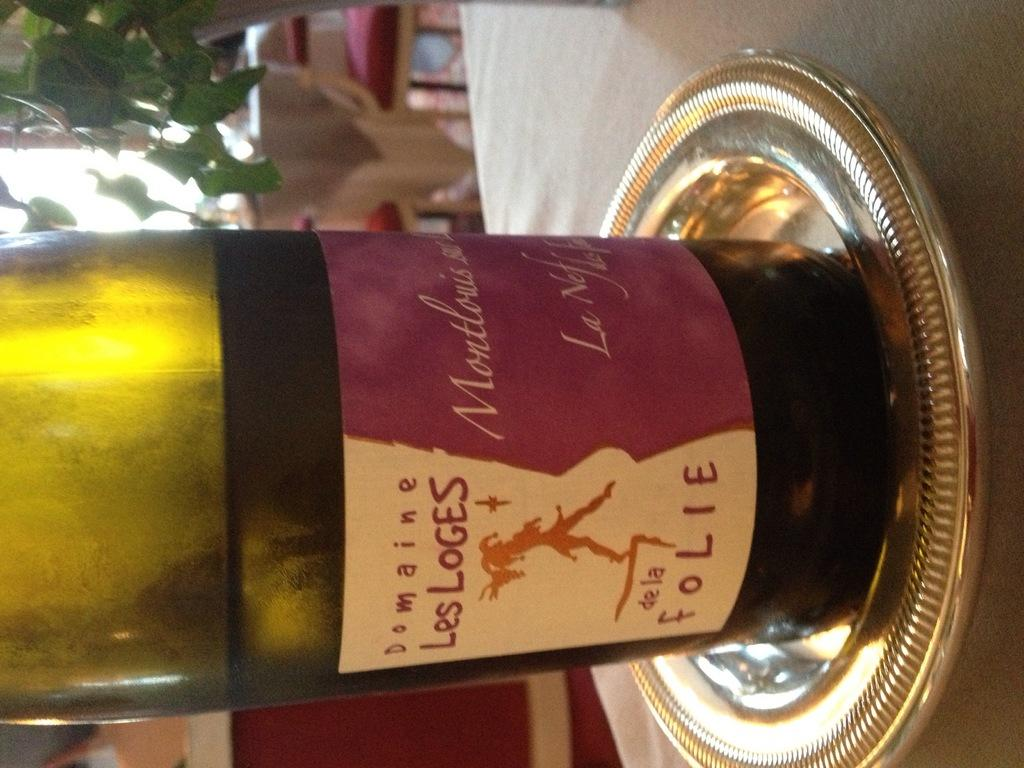<image>
Share a concise interpretation of the image provided. a bottle of wine named domaine los loges de la folie 